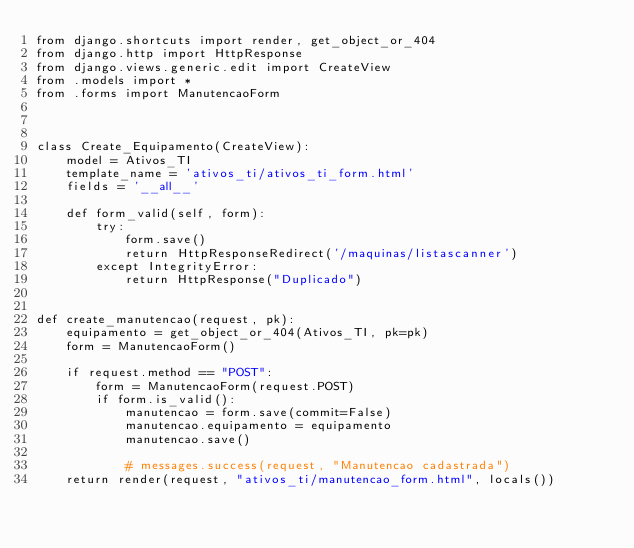Convert code to text. <code><loc_0><loc_0><loc_500><loc_500><_Python_>from django.shortcuts import render, get_object_or_404
from django.http import HttpResponse
from django.views.generic.edit import CreateView
from .models import *
from .forms import ManutencaoForm



class Create_Equipamento(CreateView):
    model = Ativos_TI
    template_name = 'ativos_ti/ativos_ti_form.html'
    fields = '__all__'

    def form_valid(self, form):
        try:
            form.save()
            return HttpResponseRedirect('/maquinas/listascanner')
        except IntegrityError:
            return HttpResponse("Duplicado")


def create_manutencao(request, pk):
    equipamento = get_object_or_404(Ativos_TI, pk=pk)
    form = ManutencaoForm()

    if request.method == "POST":
        form = ManutencaoForm(request.POST)
        if form.is_valid():
            manutencao = form.save(commit=False)
            manutencao.equipamento = equipamento
            manutencao.save()

            # messages.success(request, "Manutencao cadastrada")
    return render(request, "ativos_ti/manutencao_form.html", locals())
</code> 